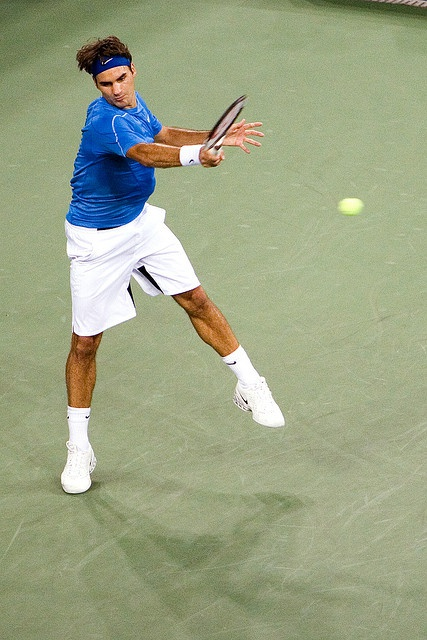Describe the objects in this image and their specific colors. I can see people in darkgreen, white, brown, blue, and navy tones, tennis racket in darkgreen, darkgray, black, and lightgray tones, and sports ball in darkgreen, khaki, lightyellow, and lightgreen tones in this image. 